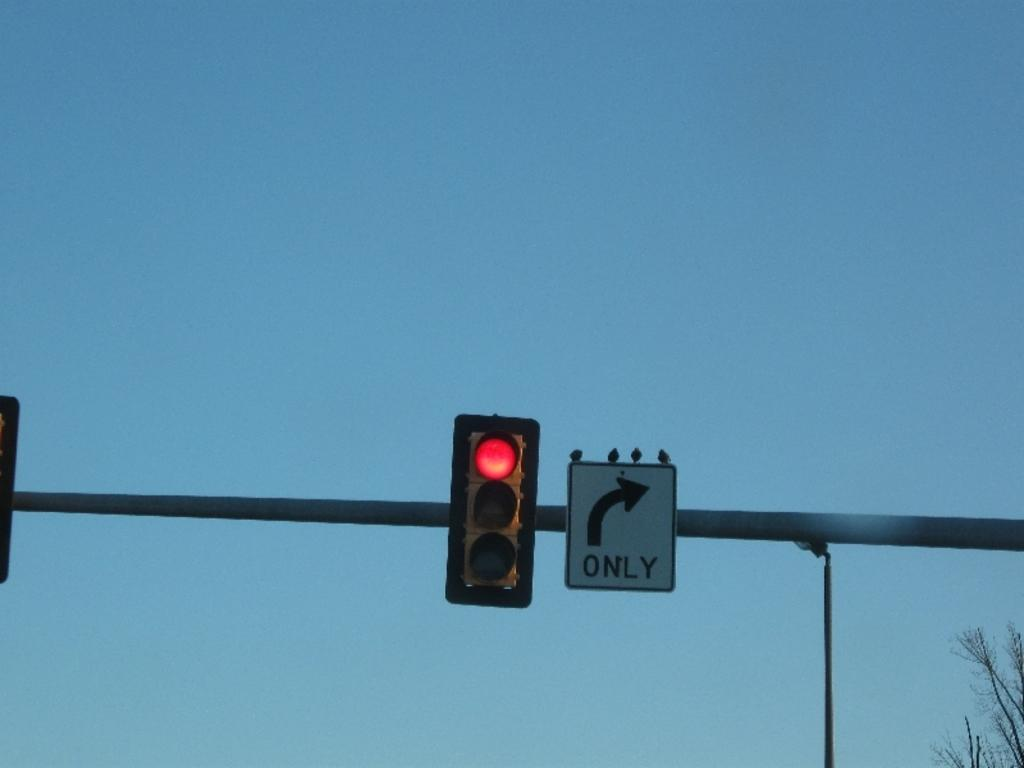<image>
Provide a brief description of the given image. A red traffic light with an arrow pointing right with the word only underneath. 